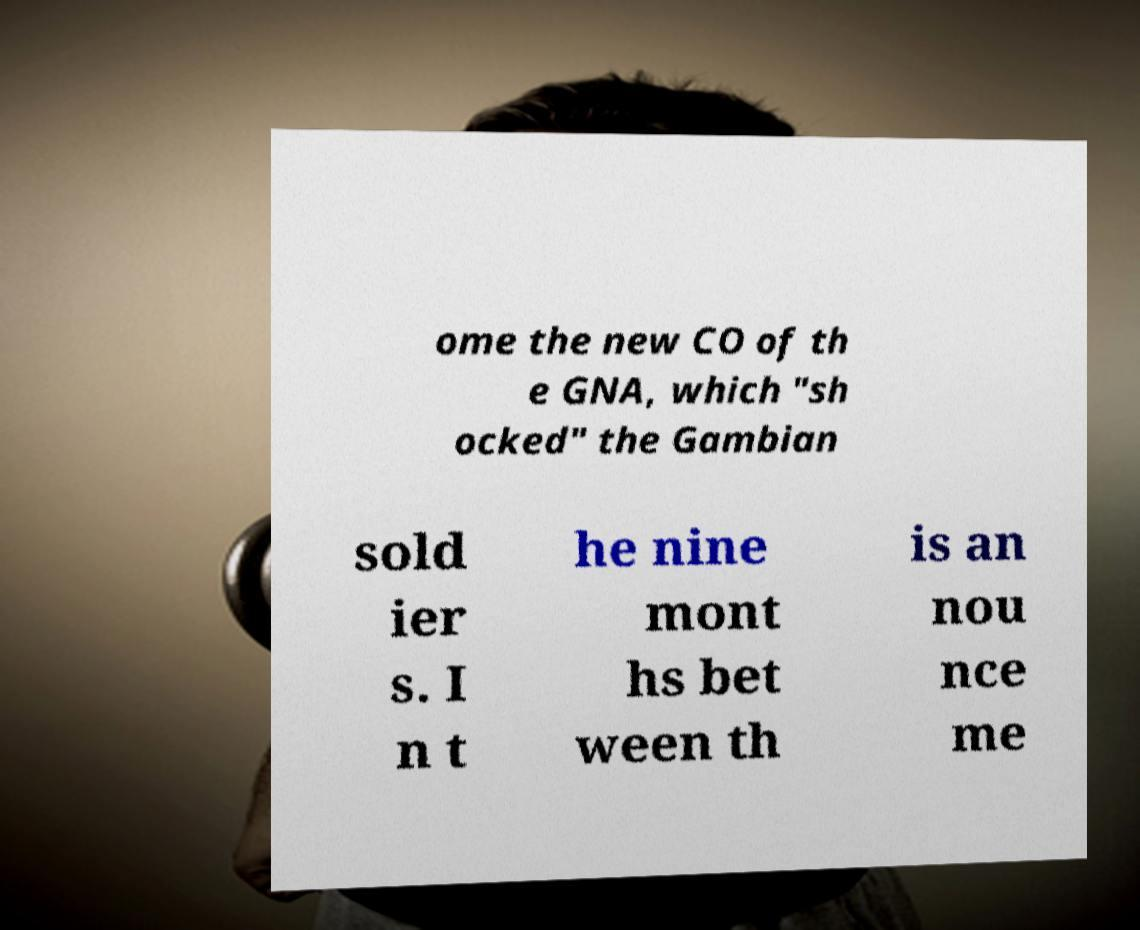Could you assist in decoding the text presented in this image and type it out clearly? ome the new CO of th e GNA, which "sh ocked" the Gambian sold ier s. I n t he nine mont hs bet ween th is an nou nce me 